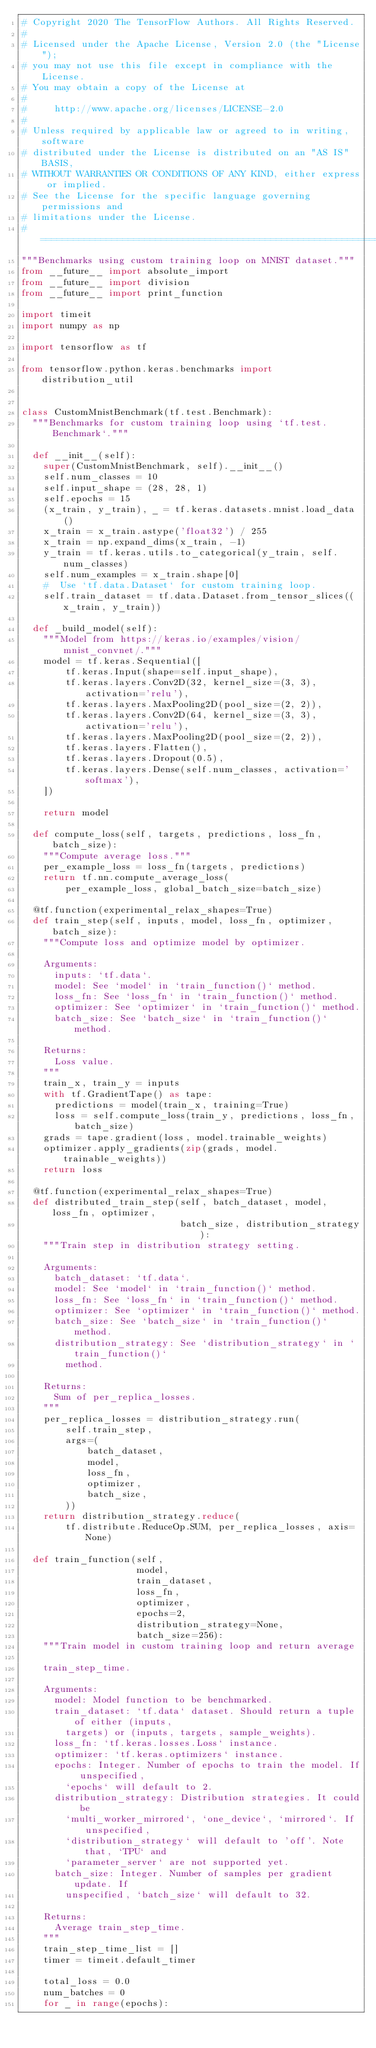Convert code to text. <code><loc_0><loc_0><loc_500><loc_500><_Python_># Copyright 2020 The TensorFlow Authors. All Rights Reserved.
#
# Licensed under the Apache License, Version 2.0 (the "License");
# you may not use this file except in compliance with the License.
# You may obtain a copy of the License at
#
#     http://www.apache.org/licenses/LICENSE-2.0
#
# Unless required by applicable law or agreed to in writing, software
# distributed under the License is distributed on an "AS IS" BASIS,
# WITHOUT WARRANTIES OR CONDITIONS OF ANY KIND, either express or implied.
# See the License for the specific language governing permissions and
# limitations under the License.
# ==============================================================================
"""Benchmarks using custom training loop on MNIST dataset."""
from __future__ import absolute_import
from __future__ import division
from __future__ import print_function

import timeit
import numpy as np

import tensorflow as tf

from tensorflow.python.keras.benchmarks import distribution_util


class CustomMnistBenchmark(tf.test.Benchmark):
  """Benchmarks for custom training loop using `tf.test.Benchmark`."""

  def __init__(self):
    super(CustomMnistBenchmark, self).__init__()
    self.num_classes = 10
    self.input_shape = (28, 28, 1)
    self.epochs = 15
    (x_train, y_train), _ = tf.keras.datasets.mnist.load_data()
    x_train = x_train.astype('float32') / 255
    x_train = np.expand_dims(x_train, -1)
    y_train = tf.keras.utils.to_categorical(y_train, self.num_classes)
    self.num_examples = x_train.shape[0]
    #  Use `tf.data.Dataset` for custom training loop.
    self.train_dataset = tf.data.Dataset.from_tensor_slices((x_train, y_train))

  def _build_model(self):
    """Model from https://keras.io/examples/vision/mnist_convnet/."""
    model = tf.keras.Sequential([
        tf.keras.Input(shape=self.input_shape),
        tf.keras.layers.Conv2D(32, kernel_size=(3, 3), activation='relu'),
        tf.keras.layers.MaxPooling2D(pool_size=(2, 2)),
        tf.keras.layers.Conv2D(64, kernel_size=(3, 3), activation='relu'),
        tf.keras.layers.MaxPooling2D(pool_size=(2, 2)),
        tf.keras.layers.Flatten(),
        tf.keras.layers.Dropout(0.5),
        tf.keras.layers.Dense(self.num_classes, activation='softmax'),
    ])

    return model

  def compute_loss(self, targets, predictions, loss_fn, batch_size):
    """Compute average loss."""
    per_example_loss = loss_fn(targets, predictions)
    return tf.nn.compute_average_loss(
        per_example_loss, global_batch_size=batch_size)

  @tf.function(experimental_relax_shapes=True)
  def train_step(self, inputs, model, loss_fn, optimizer, batch_size):
    """Compute loss and optimize model by optimizer.

    Arguments:
      inputs: `tf.data`.
      model: See `model` in `train_function()` method.
      loss_fn: See `loss_fn` in `train_function()` method.
      optimizer: See `optimizer` in `train_function()` method.
      batch_size: See `batch_size` in `train_function()` method.

    Returns:
      Loss value.
    """
    train_x, train_y = inputs
    with tf.GradientTape() as tape:
      predictions = model(train_x, training=True)
      loss = self.compute_loss(train_y, predictions, loss_fn, batch_size)
    grads = tape.gradient(loss, model.trainable_weights)
    optimizer.apply_gradients(zip(grads, model.trainable_weights))
    return loss

  @tf.function(experimental_relax_shapes=True)
  def distributed_train_step(self, batch_dataset, model, loss_fn, optimizer,
                             batch_size, distribution_strategy):
    """Train step in distribution strategy setting.

    Arguments:
      batch_dataset: `tf.data`.
      model: See `model` in `train_function()` method.
      loss_fn: See `loss_fn` in `train_function()` method.
      optimizer: See `optimizer` in `train_function()` method.
      batch_size: See `batch_size` in `train_function()` method.
      distribution_strategy: See `distribution_strategy` in `train_function()`
        method.

    Returns:
      Sum of per_replica_losses.
    """
    per_replica_losses = distribution_strategy.run(
        self.train_step,
        args=(
            batch_dataset,
            model,
            loss_fn,
            optimizer,
            batch_size,
        ))
    return distribution_strategy.reduce(
        tf.distribute.ReduceOp.SUM, per_replica_losses, axis=None)

  def train_function(self,
                     model,
                     train_dataset,
                     loss_fn,
                     optimizer,
                     epochs=2,
                     distribution_strategy=None,
                     batch_size=256):
    """Train model in custom training loop and return average

    train_step_time.

    Arguments:
      model: Model function to be benchmarked.
      train_dataset: `tf.data` dataset. Should return a tuple of either (inputs,
        targets) or (inputs, targets, sample_weights).
      loss_fn: `tf.keras.losses.Loss` instance.
      optimizer: `tf.keras.optimizers` instance.
      epochs: Integer. Number of epochs to train the model. If unspecified,
        `epochs` will default to 2.
      distribution_strategy: Distribution strategies. It could be
        `multi_worker_mirrored`, `one_device`, `mirrored`. If unspecified,
        `distribution_strategy` will default to 'off'. Note that, `TPU` and
        `parameter_server` are not supported yet.
      batch_size: Integer. Number of samples per gradient update. If
        unspecified, `batch_size` will default to 32.

    Returns:
      Average train_step_time.
    """
    train_step_time_list = []
    timer = timeit.default_timer

    total_loss = 0.0
    num_batches = 0
    for _ in range(epochs):</code> 